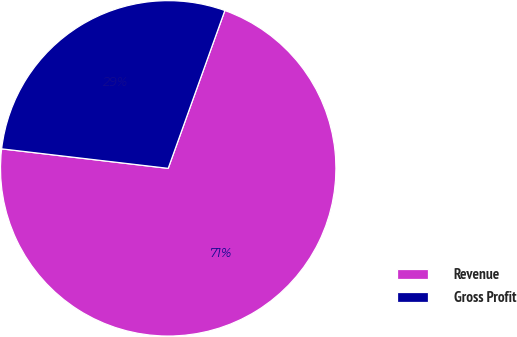Convert chart. <chart><loc_0><loc_0><loc_500><loc_500><pie_chart><fcel>Revenue<fcel>Gross Profit<nl><fcel>71.37%<fcel>28.63%<nl></chart> 